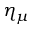Convert formula to latex. <formula><loc_0><loc_0><loc_500><loc_500>\eta _ { \mu }</formula> 